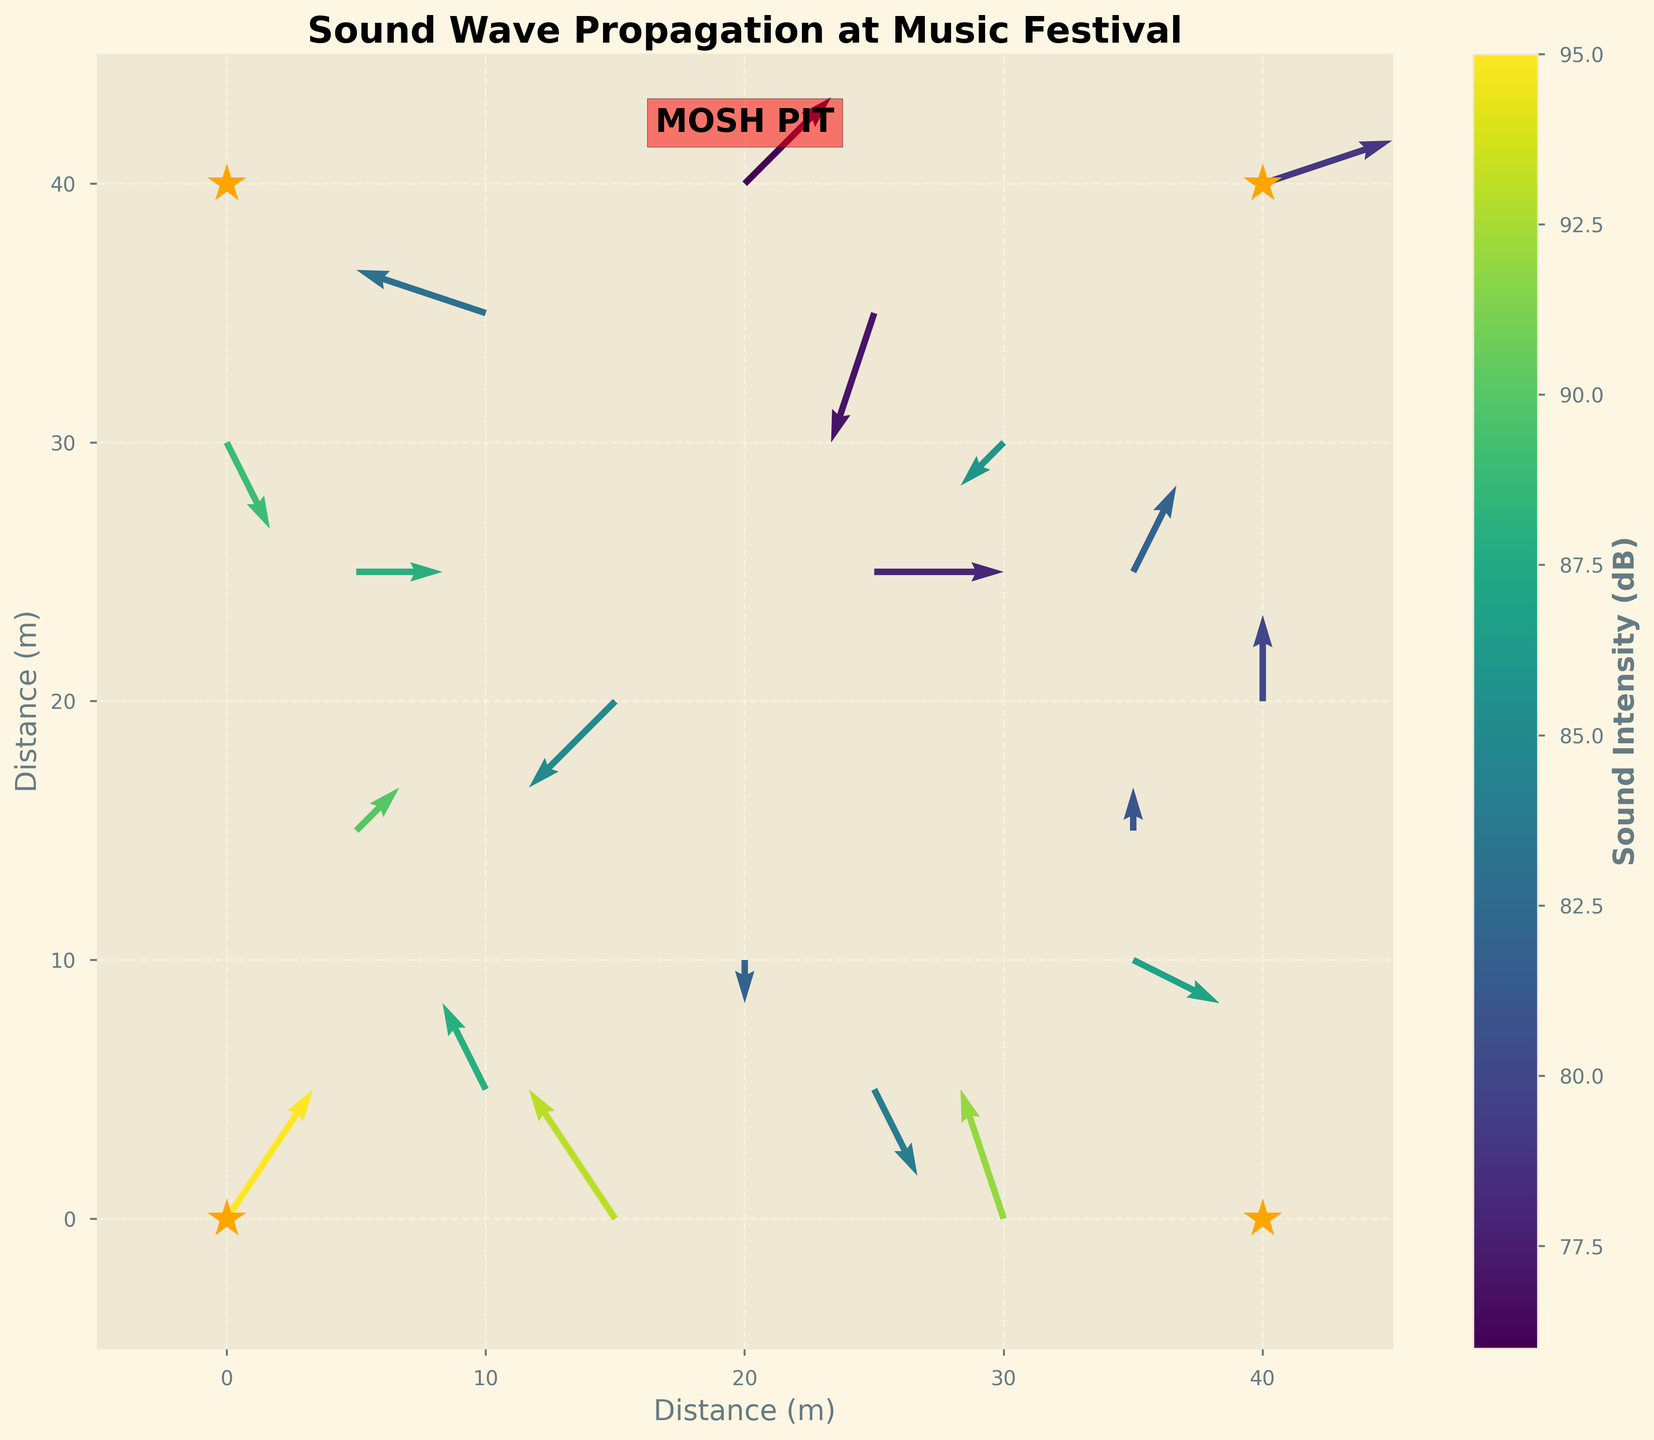What's the title of the plot? The title is usually located at the top center of the plot, displaying the subject of the visualization. In this case, the title is "Sound Wave Propagation at Music Festival".
Answer: Sound Wave Propagation at Music Festival What measurement units are used for the color bar? The color bar shows the intensity of the sound in the festival grounds in decibels (dB), as indicated by the label next to the bar.
Answer: Decibels (dB) How many speakers are marked on the plot? The speakers are marked by star symbols at four positions on the plot. These positions are (0,0), (40,0), (0,40), and (40,40).
Answer: 4 Where is the mosh pit located on the plot? The mosh pit location is labeled within the plot at coordinates (20, 42), marked with a red shaded area.
Answer: (20, 42) What is the highest sound intensity displayed on the plot? Color-coding indicates sound intensity levels. The highest value in the data provided is 95 dB, found near the speaker at (0,0).
Answer: 95 dB Compare the sound intensity at (35,10) and (25,25). Which one is higher? By examining the color coding near these points, the intensity at (35,10) is higher (87 dB) compared to (25,25) (78 dB).
Answer: (35,10) What direction is the sound wave propagating at (30,0)? The vector at (30,0) points upward with a slight leftward component, depicted by the arrow direction. This indicates a propagation direction of approximately upwards and slightly left.
Answer: Upward and slightly left How many arrows point directly downwards? Checking each vector's direction, only one arrow points directly downwards, located at (20,10).
Answer: 1 What is the sound intensity at the coordinate (15,0)? The figure indicates the color corresponding to (15,0) is within the high-intensity range, around 93 dB.
Answer: 93 dB Considering the speakers’ positions, which area has the most diverse directions of sound wave propagation? Examining the various directions of the arrows around each speaker, the area around the speaker at (0,0) shows the most diverse directions of sound wave propagation.
Answer: Around (0,0) 